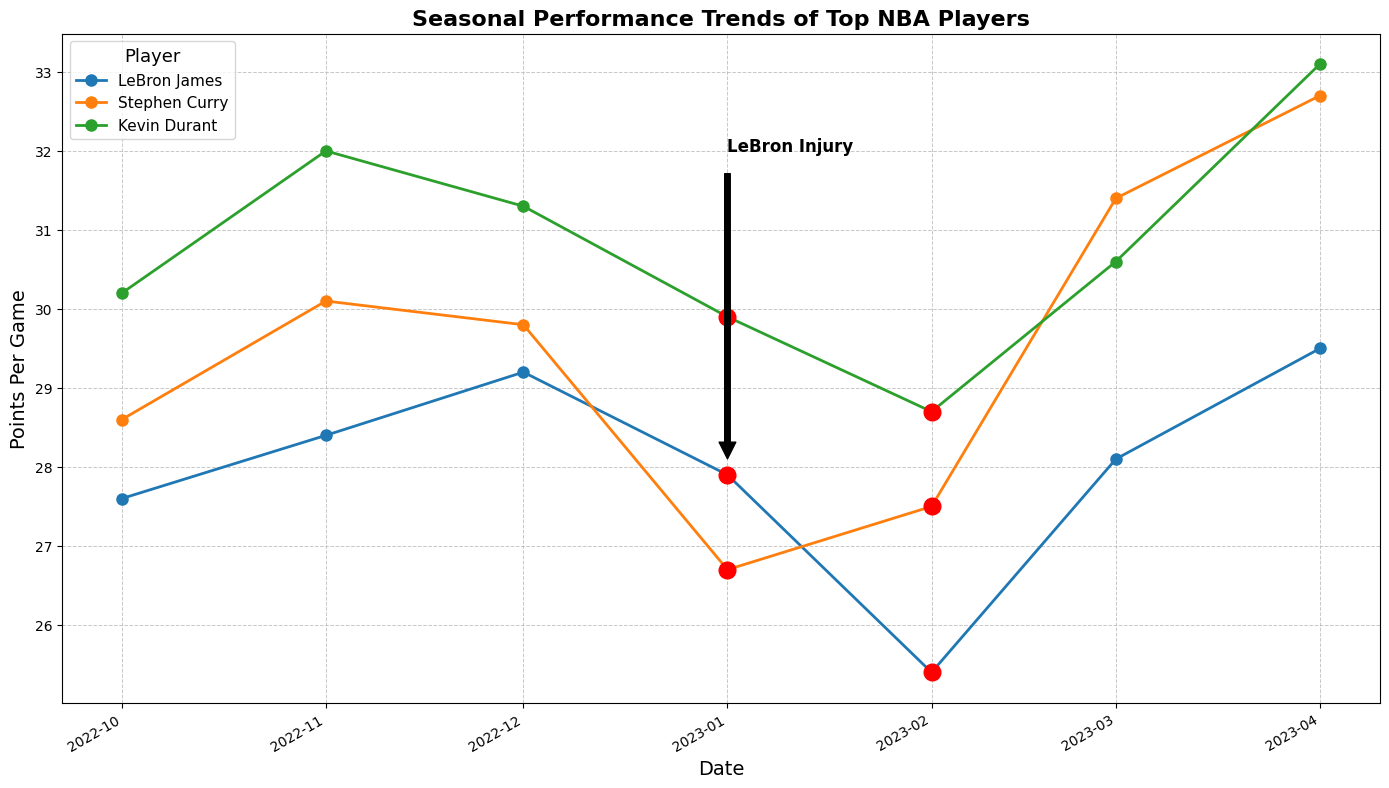What was LeBron James' Points Per Game (PPG) when he was injured in January 2023? LeBron James had an injury period highlighted in January 2023, and the corresponding PPG on that date is marked near the annotation. His PPG is 27.9.
Answer: 27.9 Who had a higher PPG in March 2023, LeBron James or Stephen Curry? In March 2023, the points for LeBron James can be seen around 28.1, while Stephen Curry's points are around 31.4. A comparison shows Stephen Curry had a higher PPG.
Answer: Stephen Curry How does Kevin Durant's PPG change from February to March 2023? In February 2023, Kevin Durant's PPG is around 28.7, and in March 2023, it is around 30.6. The change is calculated by subtracting February's PPG from March's PPG: 30.6 - 28.7 = 1.9.
Answer: Increases by 1.9 Compare the trend performance between Stephen Curry and Kevin Durant over the season. Who showed a more consistent increase in PPG? Stephen Curry exhibited a more variable trend with some dips, while Kevin Durant's trend shows a relatively steady increase over the season when their line plots are analyzed closely.
Answer: Kevin Durant What is the average PPG for Stephen Curry during his injury period? Stephen Curry's injury periods are marked in January and February 2023 with PPGs of 26.7 and 27.5 respectively. The average is calculated as (26.7 + 27.5) / 2 = 27.1.
Answer: 27.1 Which player exhibits the most significant recovery in their PPG after their injury period? By observing the line plots, Stephen Curry's PPG rises sharply from injury (27.5 in February) to 31.4 in March. This is a substantial increase compared to other players.
Answer: Stephen Curry What was the highest PPG recorded by Kevin Durant during the season, and in which month? By tracing Kevin Durant’s line, the highest point is in April 2023, where his PPG reaches 33.1.
Answer: 33.1 in April What color is used to highlight the injury periods in the chart? The injury periods in the chart are highlighted with red-colored markers.
Answer: Red How many points did LeBron James increase in his PPG from December 2022 to April 2023? LeBron James' PPG in December 2022 is 29.2, and in April 2023 it is 29.5. The increase is calculated as 29.5 - 29.2 = 0.3.
Answer: 0.3 Considering all the players during their non-injury periods, who recorded the highest PPG, and what was it? Analyzing the line plots and excluding injury periods, Stephen Curry recorded the highest PPG with 32.7 in April 2023.
Answer: Stephen Curry with 32.7 